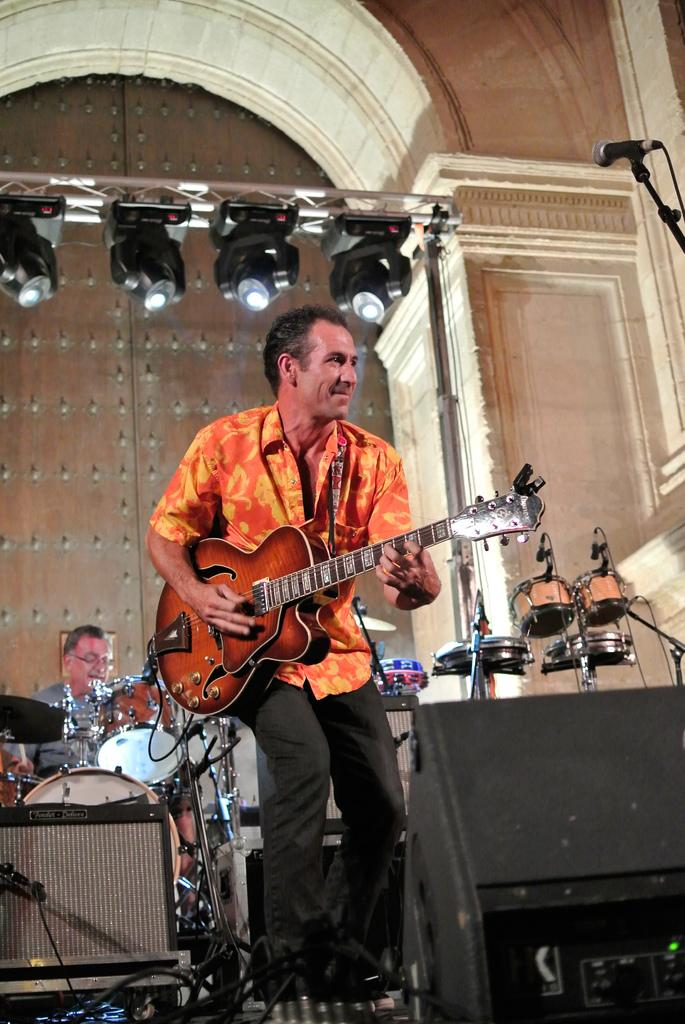What is the man in the center of the image doing? The man is standing in the center of the image and holding a guitar in his hand. What is the man's facial expression in the image? The man is smiling in the image. What is the person on the left side of the image doing? The person on the left side of the image is playing a snare drum. What type of butter is being used to tune the guitar in the image? There is no butter present in the image, and the guitar is not being tuned. 